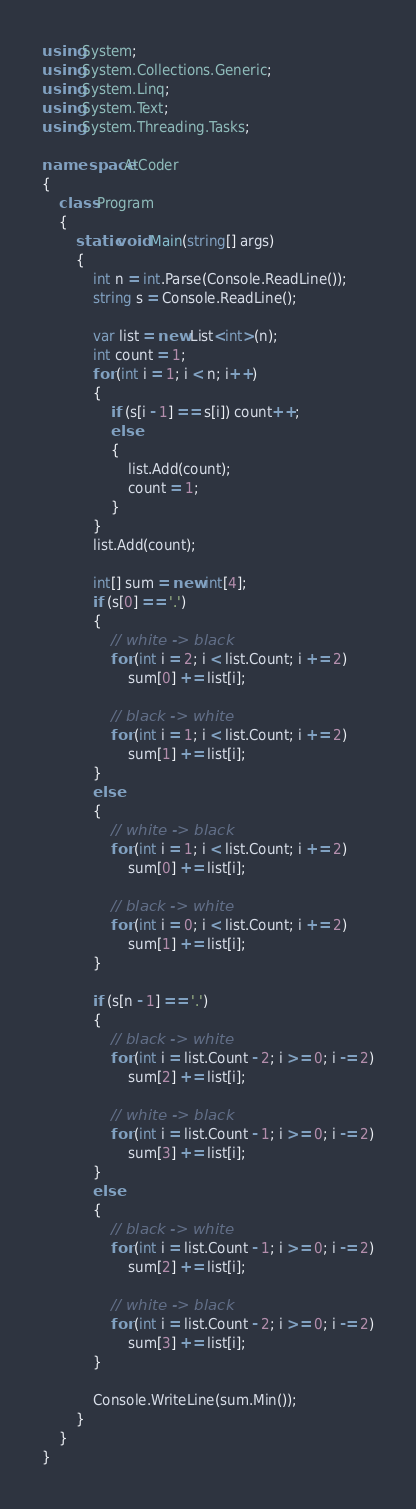<code> <loc_0><loc_0><loc_500><loc_500><_C#_>using System;
using System.Collections.Generic;
using System.Linq;
using System.Text;
using System.Threading.Tasks;

namespace AtCoder
{
    class Program
    {
        static void Main(string[] args)
        {
            int n = int.Parse(Console.ReadLine());
            string s = Console.ReadLine();

            var list = new List<int>(n);
            int count = 1;
            for (int i = 1; i < n; i++)
            {
                if (s[i - 1] == s[i]) count++;
                else
                {
                    list.Add(count);
                    count = 1;
                }
            }
            list.Add(count);

            int[] sum = new int[4];
            if (s[0] == '.')
            {
                // white -> black
                for (int i = 2; i < list.Count; i += 2)
                    sum[0] += list[i];

                // black -> white
                for (int i = 1; i < list.Count; i += 2)
                    sum[1] += list[i];
            }
            else
            {
                // white -> black
                for (int i = 1; i < list.Count; i += 2)
                    sum[0] += list[i];

                // black -> white
                for (int i = 0; i < list.Count; i += 2)
                    sum[1] += list[i];
            }

            if (s[n - 1] == '.')
            {
                // black -> white
                for (int i = list.Count - 2; i >= 0; i -= 2)
                    sum[2] += list[i];

                // white -> black
                for (int i = list.Count - 1; i >= 0; i -= 2)
                    sum[3] += list[i];
            }
            else
            {
                // black -> white
                for (int i = list.Count - 1; i >= 0; i -= 2)
                    sum[2] += list[i];

                // white -> black
                for (int i = list.Count - 2; i >= 0; i -= 2)
                    sum[3] += list[i];
            }
            
            Console.WriteLine(sum.Min());
        }
    }
}
</code> 